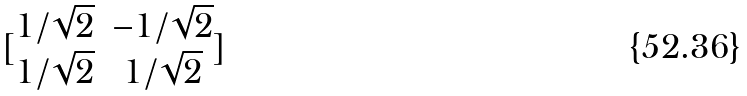Convert formula to latex. <formula><loc_0><loc_0><loc_500><loc_500>[ \begin{matrix} 1 / \sqrt { 2 } & - 1 / \sqrt { 2 } \\ 1 / \sqrt { 2 } & 1 / \sqrt { 2 } \end{matrix} ]</formula> 